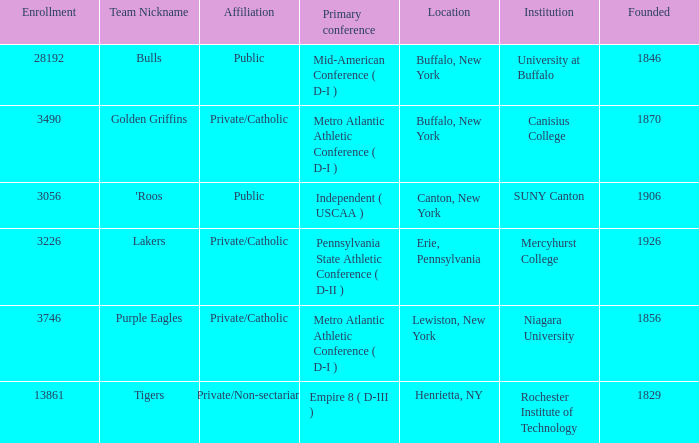Can you give me this table as a dict? {'header': ['Enrollment', 'Team Nickname', 'Affiliation', 'Primary conference', 'Location', 'Institution', 'Founded'], 'rows': [['28192', 'Bulls', 'Public', 'Mid-American Conference ( D-I )', 'Buffalo, New York', 'University at Buffalo', '1846'], ['3490', 'Golden Griffins', 'Private/Catholic', 'Metro Atlantic Athletic Conference ( D-I )', 'Buffalo, New York', 'Canisius College', '1870'], ['3056', "'Roos", 'Public', 'Independent ( USCAA )', 'Canton, New York', 'SUNY Canton', '1906'], ['3226', 'Lakers', 'Private/Catholic', 'Pennsylvania State Athletic Conference ( D-II )', 'Erie, Pennsylvania', 'Mercyhurst College', '1926'], ['3746', 'Purple Eagles', 'Private/Catholic', 'Metro Atlantic Athletic Conference ( D-I )', 'Lewiston, New York', 'Niagara University', '1856'], ['13861', 'Tigers', 'Private/Non-sectarian', 'Empire 8 ( D-III )', 'Henrietta, NY', 'Rochester Institute of Technology', '1829']]} What was the enrollment of the school founded in 1846? 28192.0. 